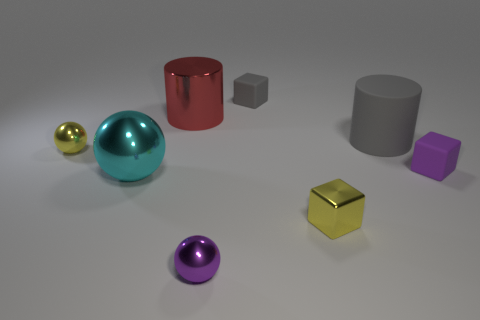Add 2 tiny yellow objects. How many objects exist? 10 Subtract all balls. How many objects are left? 5 Subtract all yellow balls. Subtract all large purple rubber blocks. How many objects are left? 7 Add 3 gray blocks. How many gray blocks are left? 4 Add 7 large gray matte cylinders. How many large gray matte cylinders exist? 8 Subtract 1 red cylinders. How many objects are left? 7 